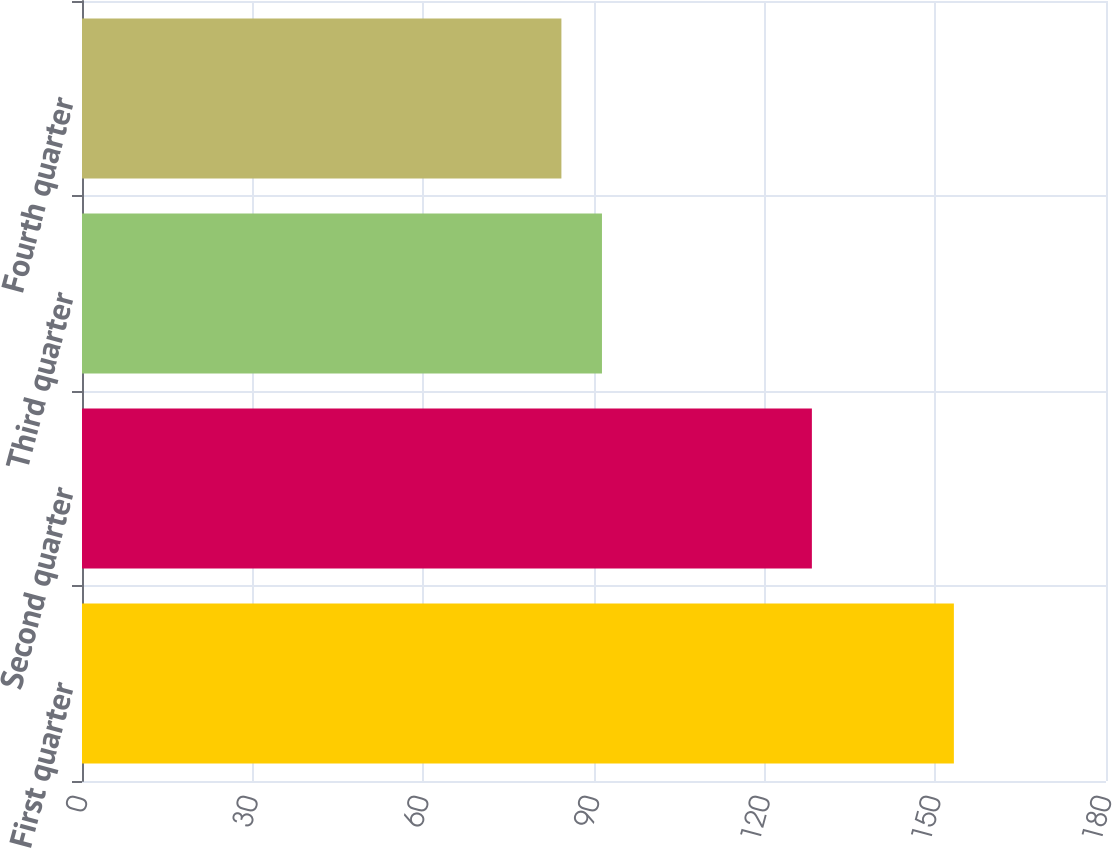Convert chart. <chart><loc_0><loc_0><loc_500><loc_500><bar_chart><fcel>First quarter<fcel>Second quarter<fcel>Third quarter<fcel>Fourth quarter<nl><fcel>153.26<fcel>128.3<fcel>91.4<fcel>84.27<nl></chart> 